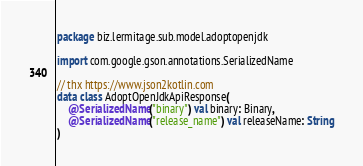<code> <loc_0><loc_0><loc_500><loc_500><_Kotlin_>package biz.lermitage.sub.model.adoptopenjdk

import com.google.gson.annotations.SerializedName

// thx https://www.json2kotlin.com
data class AdoptOpenJdkApiResponse(
    @SerializedName("binary") val binary: Binary,
    @SerializedName("release_name") val releaseName: String
)
</code> 